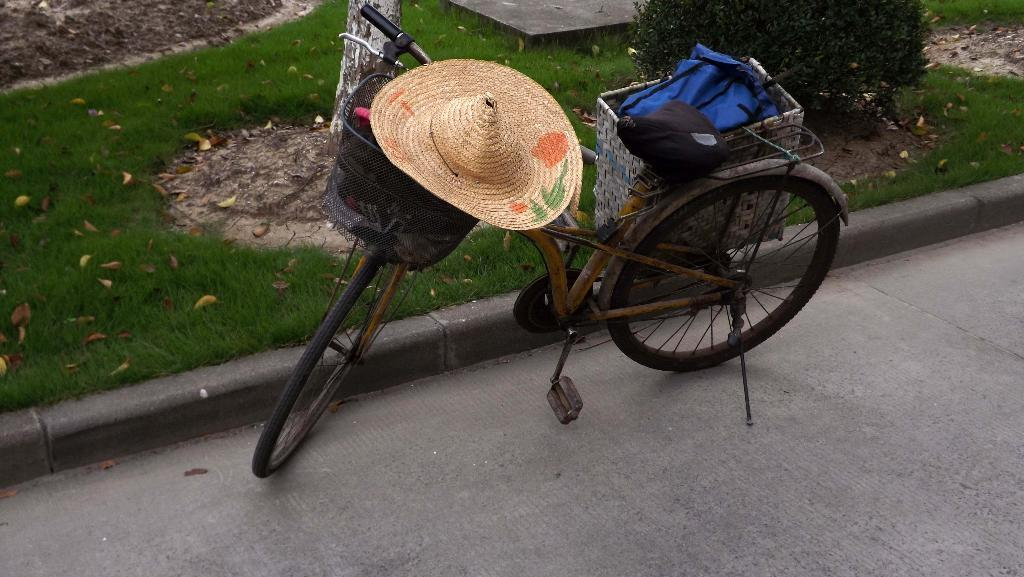What is the main subject in the center of the image? There is a cycle in the center of the image. Where is the cycle located? The cycle is on the road. What items are on the cycle? There is a hat and a bag on the cycle. What can be seen in the background of the image? There is a tree, plants, grass, and mud in the background of the image. How does the cycle get hot while riding on the road? The cycle does not get hot in the image, and there is no indication of it being ridden. 